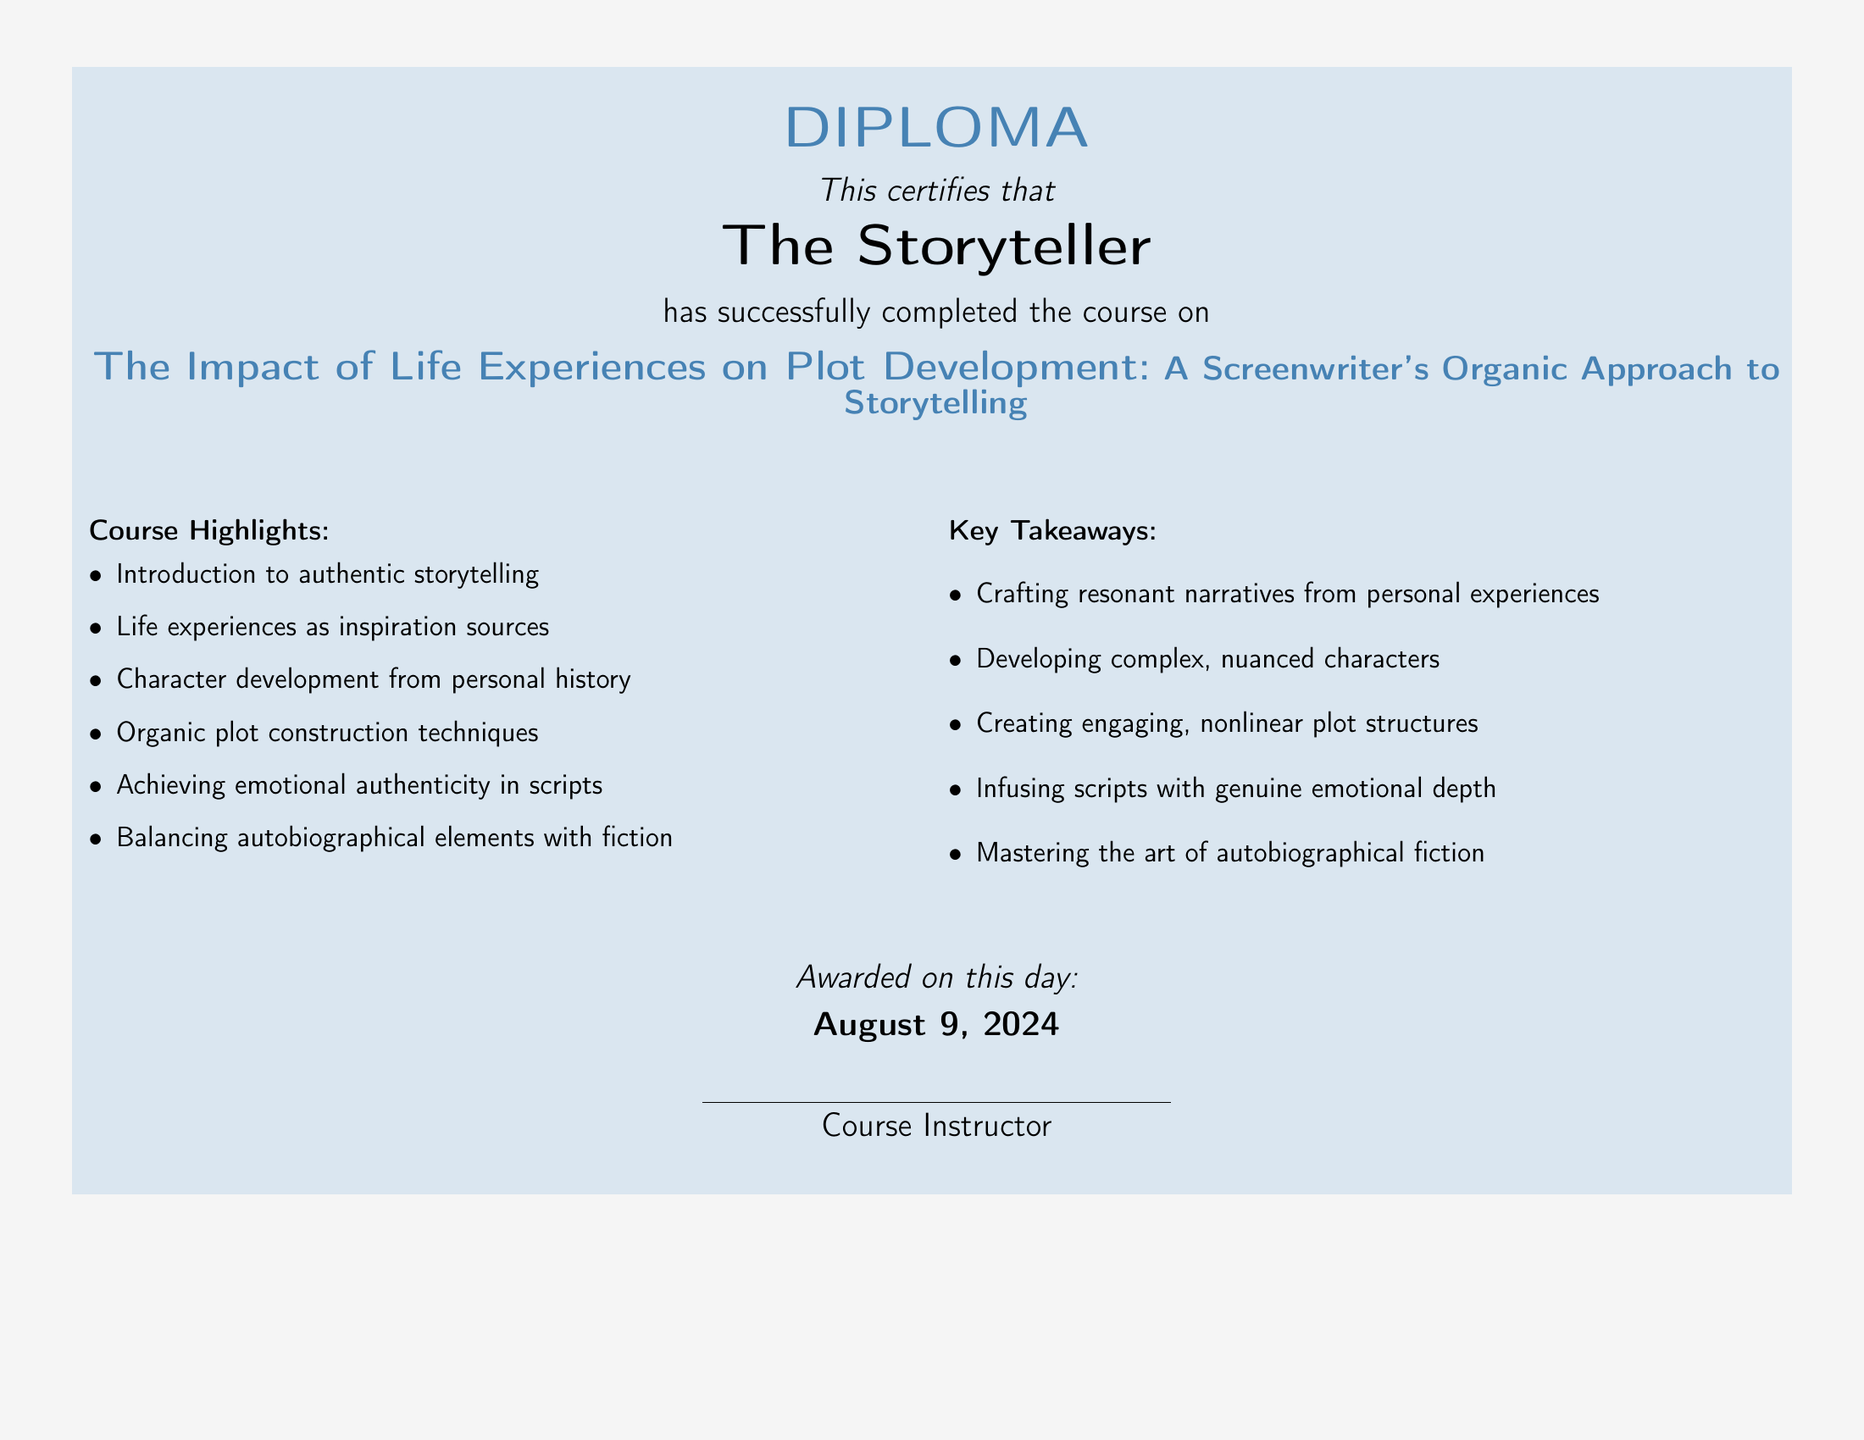What is the title of the course? The title of the course is explicitly mentioned in the document, which is the focus of the diploma.
Answer: The Impact of Life Experiences on Plot Development: A Screenwriter's Organic Approach to Storytelling Who completed the course? The document specifies the name of the individual who completed the course.
Answer: The Storyteller What is the color of the backdrop? The document describes the color used for the background of the diploma.
Answer: backdropgray On what date was the diploma awarded? The date is mentioned in the document and represented in a specific format.
Answer: today's date What is one of the course highlights? The document lists several course highlights, of which one has to be selected.
Answer: Life experiences as inspiration sources What is one of the key takeaways? The document provides a list of key takeaways from the course.
Answer: Crafting resonant narratives from personal experiences How many columns are present in the highlights and takeaways section? The layout of the document indicates the number of columns used in those sections.
Answer: 2 Who is the course instructor? The document states that there is a line for the course instructor to sign, indicating a generic title rather than a specific name.
Answer: Course Instructor 